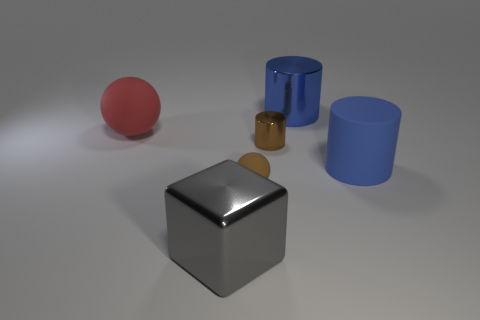Add 1 tiny blue metal objects. How many objects exist? 7 Subtract all metallic cylinders. How many cylinders are left? 1 Subtract all blue cylinders. How many cylinders are left? 1 Subtract 2 cylinders. How many cylinders are left? 1 Subtract all cyan balls. How many blue cylinders are left? 2 Subtract all cubes. How many objects are left? 5 Subtract all blue spheres. Subtract all purple cylinders. How many spheres are left? 2 Add 2 blue rubber things. How many blue rubber things are left? 3 Add 6 big rubber blocks. How many big rubber blocks exist? 6 Subtract 1 gray blocks. How many objects are left? 5 